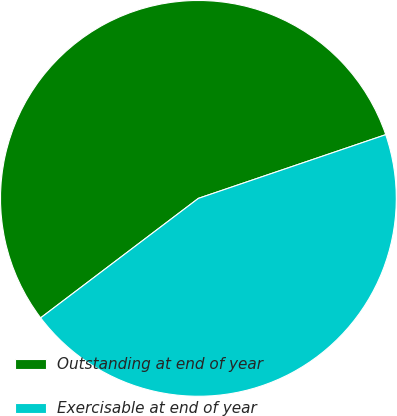Convert chart to OTSL. <chart><loc_0><loc_0><loc_500><loc_500><pie_chart><fcel>Outstanding at end of year<fcel>Exercisable at end of year<nl><fcel>55.1%<fcel>44.9%<nl></chart> 